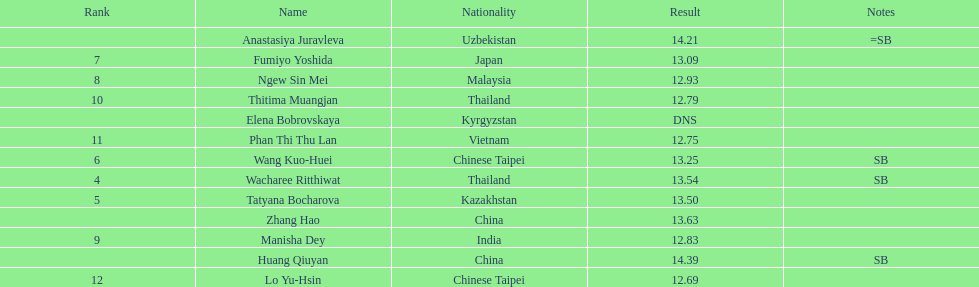How many contestants were from thailand? 2. 